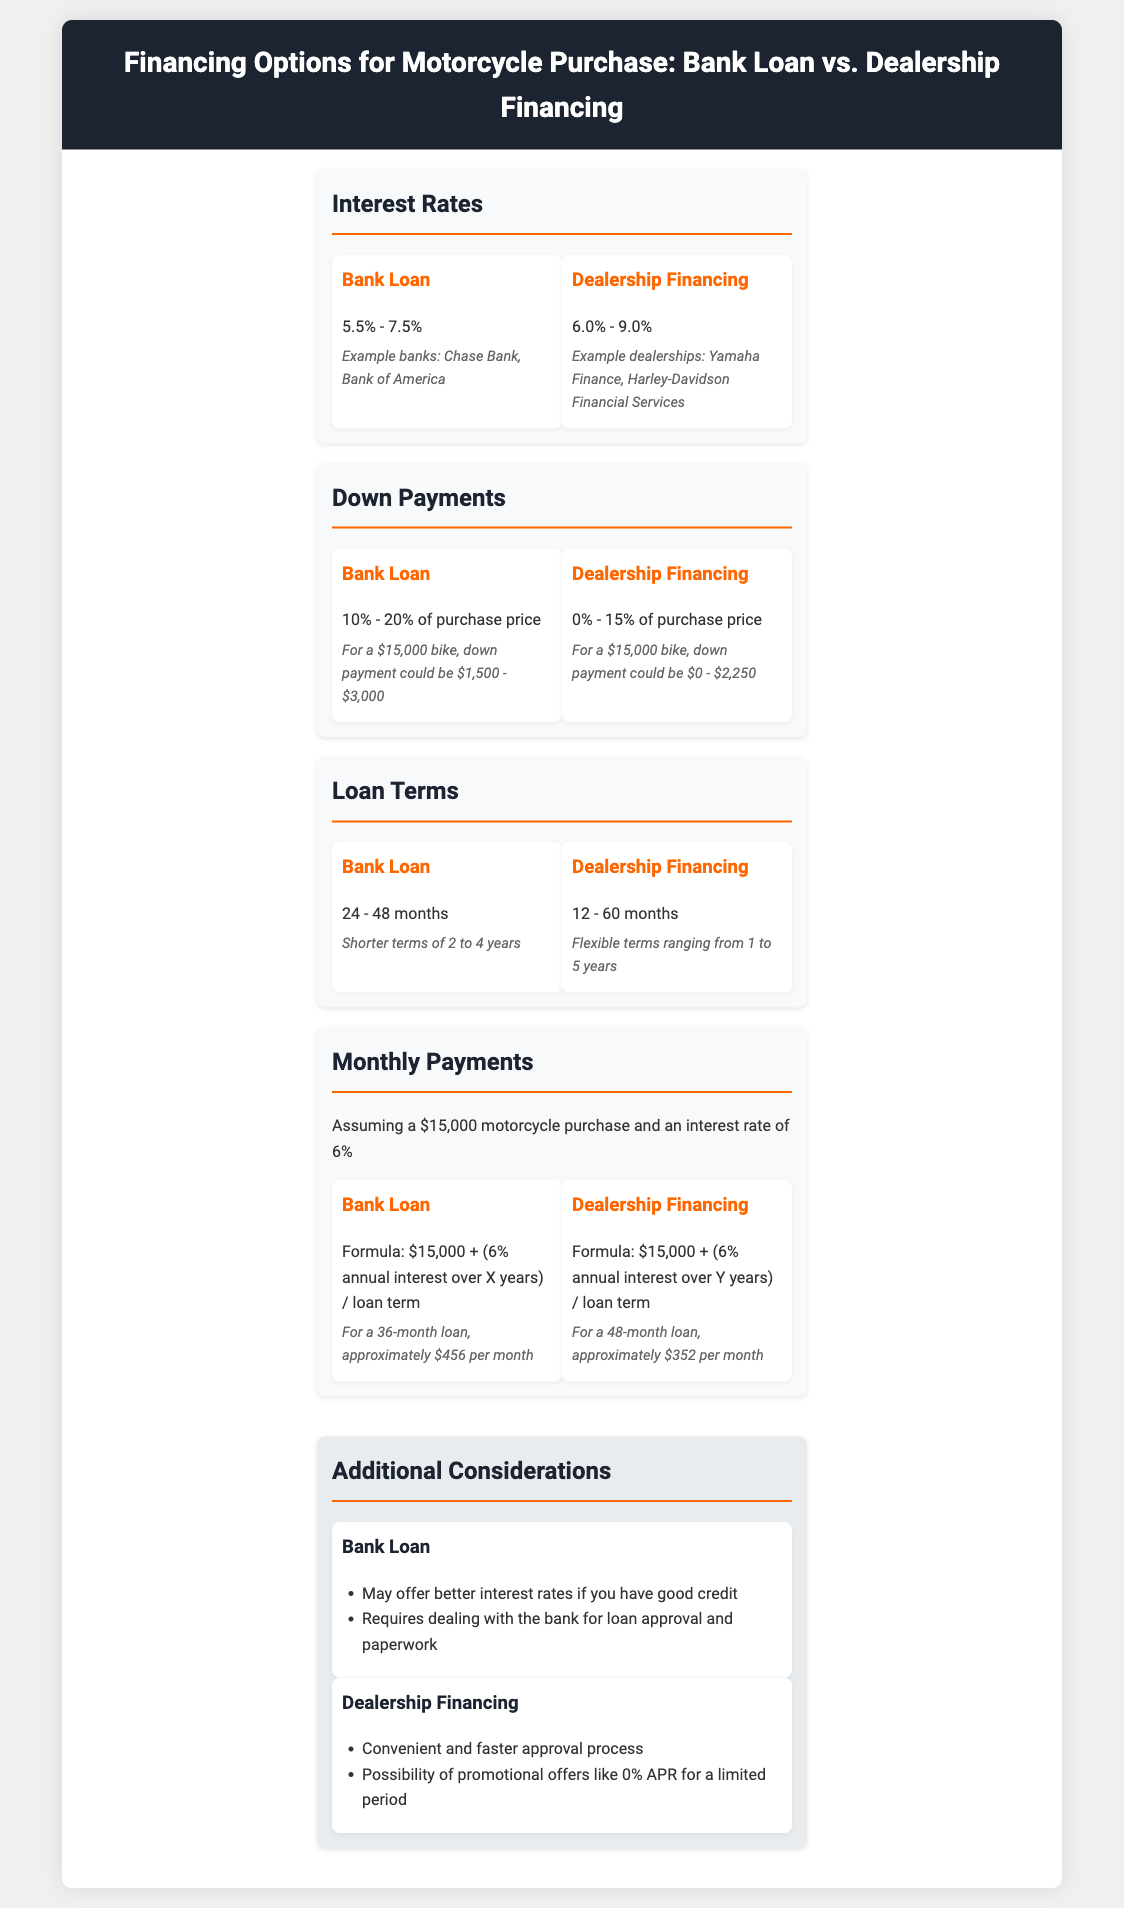what is the interest rate range for a bank loan? The document specifies the interest rate range for a bank loan as 5.5% - 7.5%.
Answer: 5.5% - 7.5% what percentage down payment is required for dealership financing? According to the document, dealership financing requires a down payment of 0% - 15% of the purchase price.
Answer: 0% - 15% what is the shortest loan term offered by a bank loan? The document states that the shortest loan term for a bank loan is 24 months.
Answer: 24 months how much would the monthly payment be for a 36-month bank loan? The document indicates that for a 36-month bank loan, the monthly payment would be approximately $456.
Answer: $456 which financing option may offer better interest rates for someone with good credit? The document notes that bank loans may offer better interest rates if you have good credit.
Answer: Bank Loan what is the maximum loan term for dealership financing? The document mentions that the maximum loan term for dealership financing is 60 months.
Answer: 60 months what is a possible promotional offer mentioned for dealership financing? The document states that dealership financing may include promotional offers like 0% APR for a limited period.
Answer: 0% APR which financing option requires dealing with the bank for loan approval? The document highlights that bank loans require dealing with the bank for loan approval and paperwork.
Answer: Bank Loan what is the down payment range for a $15,000 bike under bank loan? The document specifies that the down payment for a $15,000 motorcycle under a bank loan could be $1,500 - $3,000.
Answer: $1,500 - $3,000 